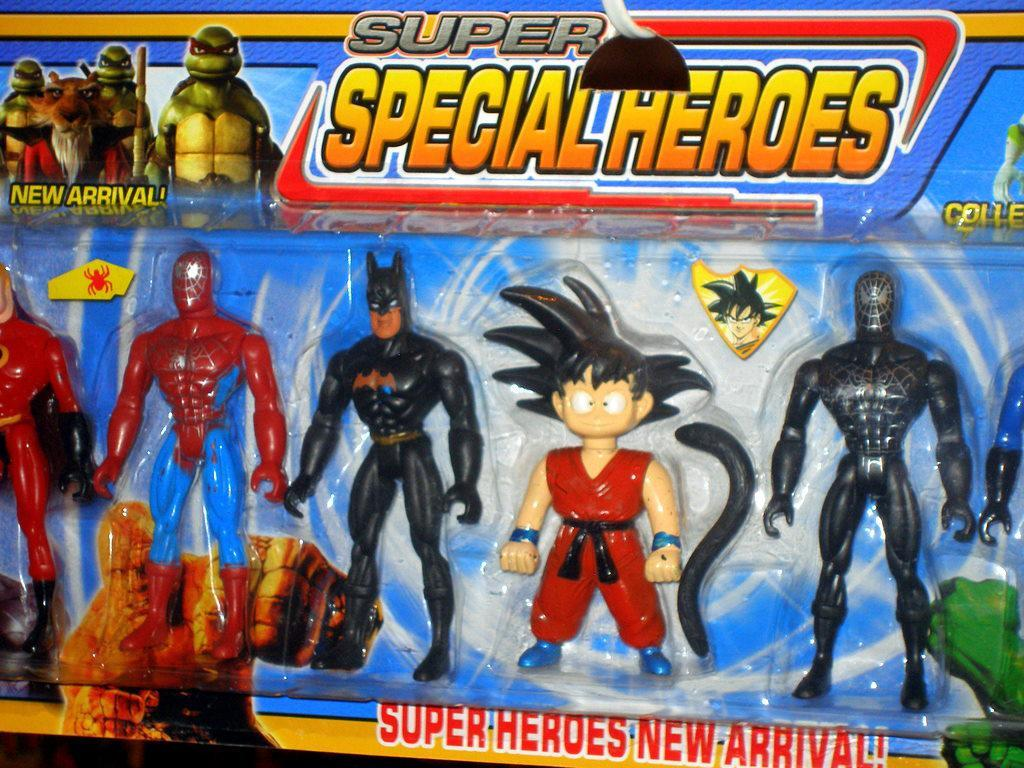<image>
Write a terse but informative summary of the picture. A collection of Super Heroes that is a new arrival. 